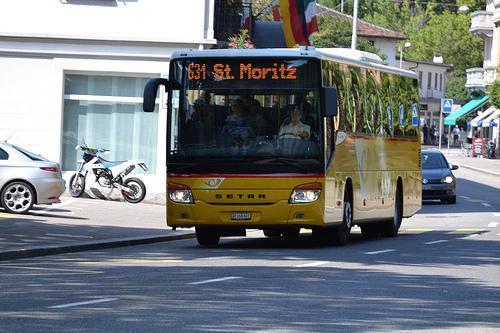How many buses are in the photo?
Give a very brief answer. 1. How many motorbikes are in this photo?
Give a very brief answer. 1. How many wheels does the bus have?
Give a very brief answer. 4. 